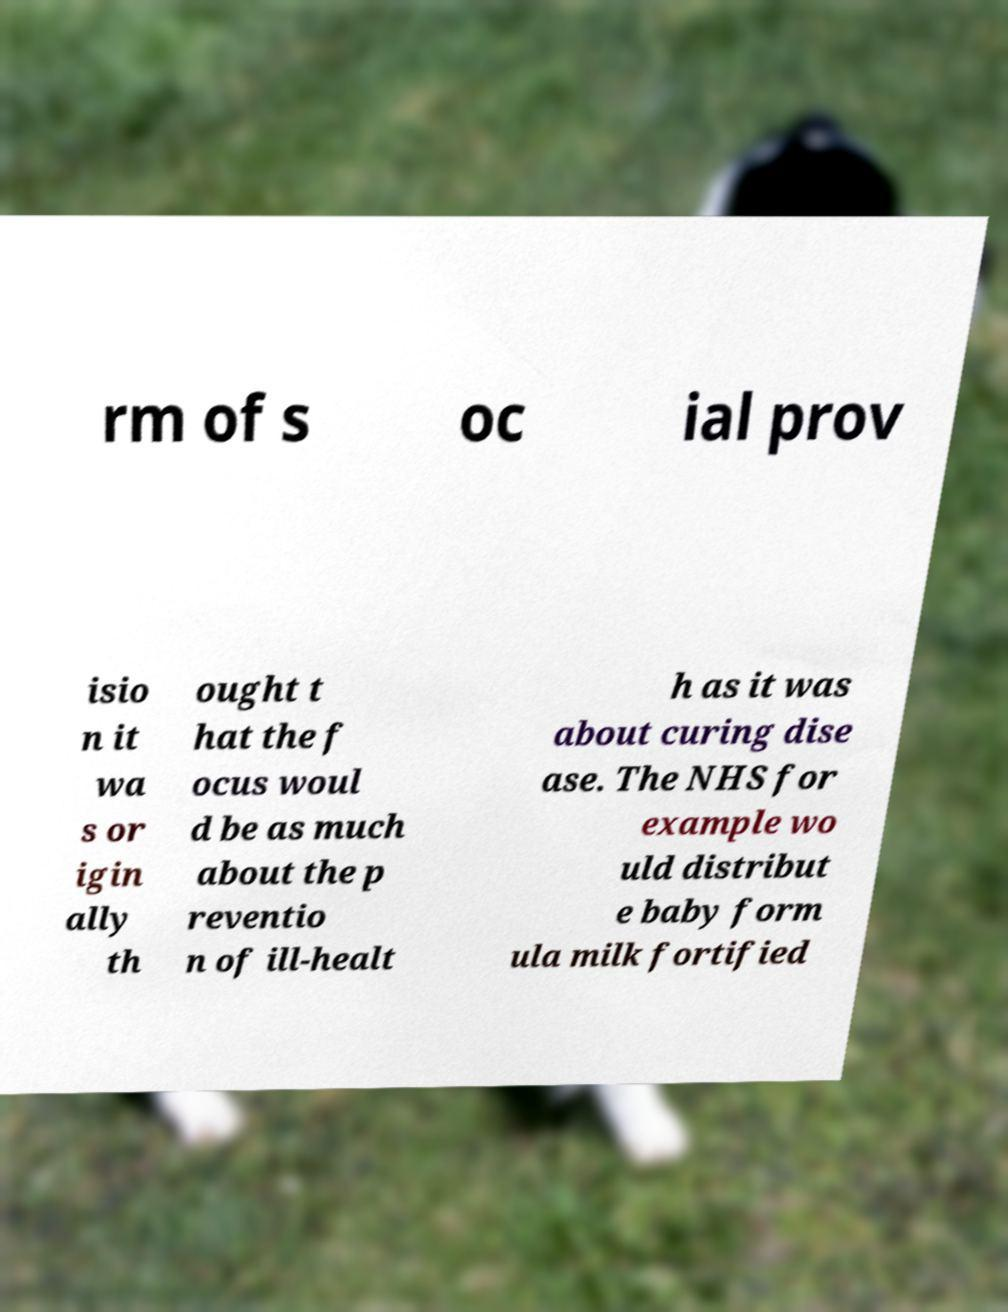There's text embedded in this image that I need extracted. Can you transcribe it verbatim? rm of s oc ial prov isio n it wa s or igin ally th ought t hat the f ocus woul d be as much about the p reventio n of ill-healt h as it was about curing dise ase. The NHS for example wo uld distribut e baby form ula milk fortified 